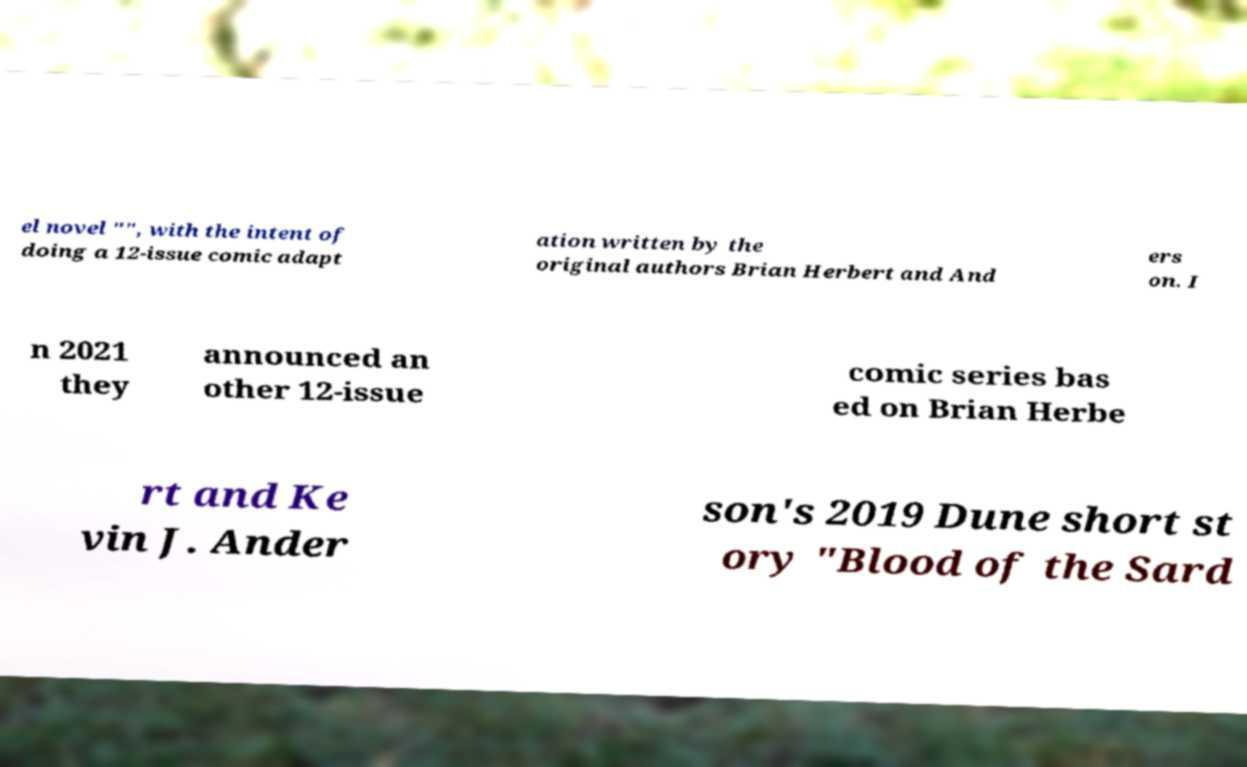Can you accurately transcribe the text from the provided image for me? el novel "", with the intent of doing a 12-issue comic adapt ation written by the original authors Brian Herbert and And ers on. I n 2021 they announced an other 12-issue comic series bas ed on Brian Herbe rt and Ke vin J. Ander son's 2019 Dune short st ory "Blood of the Sard 